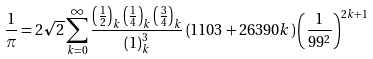Convert formula to latex. <formula><loc_0><loc_0><loc_500><loc_500>\frac { 1 } { \pi } = 2 \sqrt { 2 } \sum _ { k = 0 } ^ { \infty } \frac { \left ( \frac { 1 } { 2 } \right ) _ { k } \left ( \frac { 1 } { 4 } \right ) _ { k } \left ( \frac { 3 } { 4 } \right ) _ { k } } { ( 1 ) _ { k } ^ { 3 } } \left ( 1 1 0 3 + 2 6 3 9 0 k \right ) \left ( \frac { 1 } { 9 9 ^ { 2 } } \right ) ^ { 2 k + 1 }</formula> 